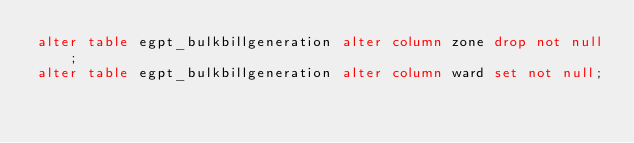<code> <loc_0><loc_0><loc_500><loc_500><_SQL_>alter table egpt_bulkbillgeneration alter column zone drop not null;
alter table egpt_bulkbillgeneration alter column ward set not null;</code> 